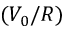<formula> <loc_0><loc_0><loc_500><loc_500>( V _ { 0 } / R )</formula> 